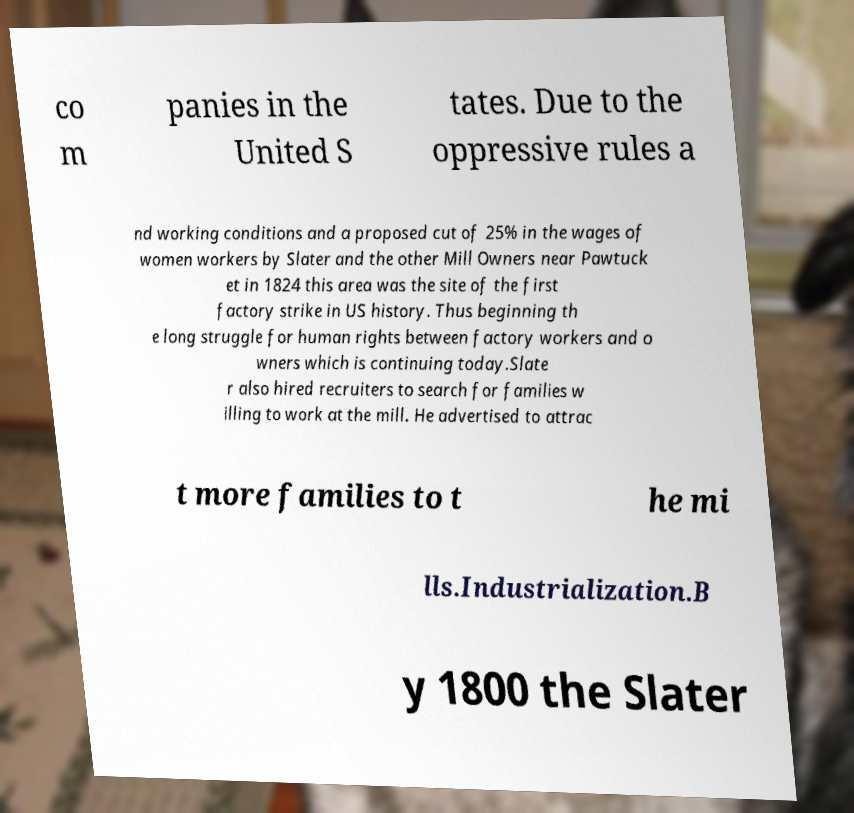I need the written content from this picture converted into text. Can you do that? co m panies in the United S tates. Due to the oppressive rules a nd working conditions and a proposed cut of 25% in the wages of women workers by Slater and the other Mill Owners near Pawtuck et in 1824 this area was the site of the first factory strike in US history. Thus beginning th e long struggle for human rights between factory workers and o wners which is continuing today.Slate r also hired recruiters to search for families w illing to work at the mill. He advertised to attrac t more families to t he mi lls.Industrialization.B y 1800 the Slater 